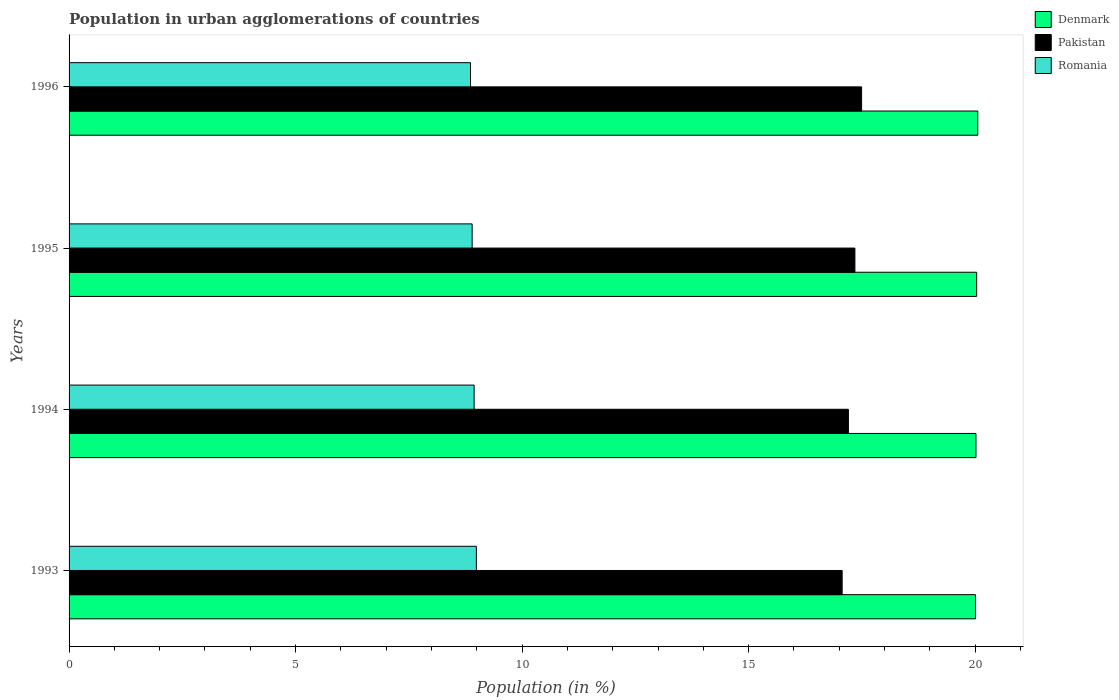How many groups of bars are there?
Provide a succinct answer. 4. Are the number of bars per tick equal to the number of legend labels?
Your answer should be compact. Yes. Are the number of bars on each tick of the Y-axis equal?
Provide a short and direct response. Yes. In how many cases, is the number of bars for a given year not equal to the number of legend labels?
Give a very brief answer. 0. What is the percentage of population in urban agglomerations in Romania in 1994?
Your answer should be compact. 8.94. Across all years, what is the maximum percentage of population in urban agglomerations in Pakistan?
Keep it short and to the point. 17.49. Across all years, what is the minimum percentage of population in urban agglomerations in Romania?
Your answer should be compact. 8.86. In which year was the percentage of population in urban agglomerations in Pakistan maximum?
Offer a very short reply. 1996. In which year was the percentage of population in urban agglomerations in Romania minimum?
Your response must be concise. 1996. What is the total percentage of population in urban agglomerations in Pakistan in the graph?
Make the answer very short. 69.1. What is the difference between the percentage of population in urban agglomerations in Denmark in 1993 and that in 1994?
Make the answer very short. -0.01. What is the difference between the percentage of population in urban agglomerations in Pakistan in 1996 and the percentage of population in urban agglomerations in Romania in 1995?
Ensure brevity in your answer.  8.6. What is the average percentage of population in urban agglomerations in Pakistan per year?
Your answer should be compact. 17.28. In the year 1996, what is the difference between the percentage of population in urban agglomerations in Pakistan and percentage of population in urban agglomerations in Denmark?
Keep it short and to the point. -2.56. What is the ratio of the percentage of population in urban agglomerations in Denmark in 1995 to that in 1996?
Your answer should be very brief. 1. Is the percentage of population in urban agglomerations in Romania in 1995 less than that in 1996?
Provide a short and direct response. No. Is the difference between the percentage of population in urban agglomerations in Pakistan in 1994 and 1995 greater than the difference between the percentage of population in urban agglomerations in Denmark in 1994 and 1995?
Ensure brevity in your answer.  No. What is the difference between the highest and the second highest percentage of population in urban agglomerations in Pakistan?
Offer a very short reply. 0.15. What is the difference between the highest and the lowest percentage of population in urban agglomerations in Pakistan?
Your answer should be compact. 0.43. In how many years, is the percentage of population in urban agglomerations in Denmark greater than the average percentage of population in urban agglomerations in Denmark taken over all years?
Keep it short and to the point. 2. Is the sum of the percentage of population in urban agglomerations in Pakistan in 1993 and 1995 greater than the maximum percentage of population in urban agglomerations in Romania across all years?
Keep it short and to the point. Yes. What does the 2nd bar from the top in 1996 represents?
Give a very brief answer. Pakistan. What does the 3rd bar from the bottom in 1993 represents?
Make the answer very short. Romania. Is it the case that in every year, the sum of the percentage of population in urban agglomerations in Romania and percentage of population in urban agglomerations in Denmark is greater than the percentage of population in urban agglomerations in Pakistan?
Give a very brief answer. Yes. How many bars are there?
Your response must be concise. 12. Are all the bars in the graph horizontal?
Provide a short and direct response. Yes. What is the difference between two consecutive major ticks on the X-axis?
Your response must be concise. 5. Does the graph contain grids?
Offer a terse response. No. Where does the legend appear in the graph?
Your response must be concise. Top right. How many legend labels are there?
Your response must be concise. 3. What is the title of the graph?
Ensure brevity in your answer.  Population in urban agglomerations of countries. What is the label or title of the Y-axis?
Your answer should be very brief. Years. What is the Population (in %) of Denmark in 1993?
Your answer should be compact. 20.01. What is the Population (in %) in Pakistan in 1993?
Keep it short and to the point. 17.06. What is the Population (in %) of Romania in 1993?
Ensure brevity in your answer.  8.99. What is the Population (in %) in Denmark in 1994?
Offer a very short reply. 20.02. What is the Population (in %) of Pakistan in 1994?
Ensure brevity in your answer.  17.2. What is the Population (in %) in Romania in 1994?
Provide a short and direct response. 8.94. What is the Population (in %) in Denmark in 1995?
Make the answer very short. 20.03. What is the Population (in %) in Pakistan in 1995?
Provide a succinct answer. 17.35. What is the Population (in %) in Romania in 1995?
Keep it short and to the point. 8.9. What is the Population (in %) of Denmark in 1996?
Give a very brief answer. 20.06. What is the Population (in %) in Pakistan in 1996?
Your answer should be compact. 17.49. What is the Population (in %) of Romania in 1996?
Your response must be concise. 8.86. Across all years, what is the maximum Population (in %) in Denmark?
Provide a succinct answer. 20.06. Across all years, what is the maximum Population (in %) of Pakistan?
Offer a very short reply. 17.49. Across all years, what is the maximum Population (in %) in Romania?
Offer a very short reply. 8.99. Across all years, what is the minimum Population (in %) of Denmark?
Make the answer very short. 20.01. Across all years, what is the minimum Population (in %) of Pakistan?
Offer a very short reply. 17.06. Across all years, what is the minimum Population (in %) of Romania?
Provide a short and direct response. 8.86. What is the total Population (in %) of Denmark in the graph?
Your response must be concise. 80.11. What is the total Population (in %) of Pakistan in the graph?
Make the answer very short. 69.1. What is the total Population (in %) of Romania in the graph?
Provide a short and direct response. 35.69. What is the difference between the Population (in %) of Denmark in 1993 and that in 1994?
Make the answer very short. -0.01. What is the difference between the Population (in %) of Pakistan in 1993 and that in 1994?
Your response must be concise. -0.14. What is the difference between the Population (in %) in Romania in 1993 and that in 1994?
Your answer should be very brief. 0.05. What is the difference between the Population (in %) in Denmark in 1993 and that in 1995?
Your response must be concise. -0.03. What is the difference between the Population (in %) in Pakistan in 1993 and that in 1995?
Offer a very short reply. -0.28. What is the difference between the Population (in %) of Romania in 1993 and that in 1995?
Ensure brevity in your answer.  0.09. What is the difference between the Population (in %) of Denmark in 1993 and that in 1996?
Your answer should be very brief. -0.05. What is the difference between the Population (in %) of Pakistan in 1993 and that in 1996?
Your response must be concise. -0.43. What is the difference between the Population (in %) in Romania in 1993 and that in 1996?
Provide a short and direct response. 0.13. What is the difference between the Population (in %) in Denmark in 1994 and that in 1995?
Make the answer very short. -0.01. What is the difference between the Population (in %) of Pakistan in 1994 and that in 1995?
Offer a terse response. -0.14. What is the difference between the Population (in %) in Romania in 1994 and that in 1995?
Keep it short and to the point. 0.04. What is the difference between the Population (in %) of Denmark in 1994 and that in 1996?
Make the answer very short. -0.04. What is the difference between the Population (in %) of Pakistan in 1994 and that in 1996?
Your response must be concise. -0.29. What is the difference between the Population (in %) of Romania in 1994 and that in 1996?
Keep it short and to the point. 0.08. What is the difference between the Population (in %) of Denmark in 1995 and that in 1996?
Ensure brevity in your answer.  -0.03. What is the difference between the Population (in %) in Pakistan in 1995 and that in 1996?
Provide a succinct answer. -0.15. What is the difference between the Population (in %) of Romania in 1995 and that in 1996?
Make the answer very short. 0.04. What is the difference between the Population (in %) of Denmark in 1993 and the Population (in %) of Pakistan in 1994?
Offer a terse response. 2.8. What is the difference between the Population (in %) of Denmark in 1993 and the Population (in %) of Romania in 1994?
Your answer should be very brief. 11.06. What is the difference between the Population (in %) of Pakistan in 1993 and the Population (in %) of Romania in 1994?
Give a very brief answer. 8.12. What is the difference between the Population (in %) in Denmark in 1993 and the Population (in %) in Pakistan in 1995?
Provide a succinct answer. 2.66. What is the difference between the Population (in %) in Denmark in 1993 and the Population (in %) in Romania in 1995?
Your response must be concise. 11.11. What is the difference between the Population (in %) of Pakistan in 1993 and the Population (in %) of Romania in 1995?
Provide a succinct answer. 8.17. What is the difference between the Population (in %) in Denmark in 1993 and the Population (in %) in Pakistan in 1996?
Provide a succinct answer. 2.51. What is the difference between the Population (in %) in Denmark in 1993 and the Population (in %) in Romania in 1996?
Keep it short and to the point. 11.14. What is the difference between the Population (in %) of Pakistan in 1993 and the Population (in %) of Romania in 1996?
Your response must be concise. 8.2. What is the difference between the Population (in %) of Denmark in 1994 and the Population (in %) of Pakistan in 1995?
Make the answer very short. 2.67. What is the difference between the Population (in %) of Denmark in 1994 and the Population (in %) of Romania in 1995?
Keep it short and to the point. 11.12. What is the difference between the Population (in %) in Pakistan in 1994 and the Population (in %) in Romania in 1995?
Your answer should be very brief. 8.3. What is the difference between the Population (in %) of Denmark in 1994 and the Population (in %) of Pakistan in 1996?
Provide a short and direct response. 2.52. What is the difference between the Population (in %) of Denmark in 1994 and the Population (in %) of Romania in 1996?
Provide a short and direct response. 11.16. What is the difference between the Population (in %) in Pakistan in 1994 and the Population (in %) in Romania in 1996?
Offer a terse response. 8.34. What is the difference between the Population (in %) in Denmark in 1995 and the Population (in %) in Pakistan in 1996?
Give a very brief answer. 2.54. What is the difference between the Population (in %) in Denmark in 1995 and the Population (in %) in Romania in 1996?
Give a very brief answer. 11.17. What is the difference between the Population (in %) in Pakistan in 1995 and the Population (in %) in Romania in 1996?
Provide a short and direct response. 8.48. What is the average Population (in %) of Denmark per year?
Provide a succinct answer. 20.03. What is the average Population (in %) in Pakistan per year?
Keep it short and to the point. 17.28. What is the average Population (in %) in Romania per year?
Ensure brevity in your answer.  8.92. In the year 1993, what is the difference between the Population (in %) in Denmark and Population (in %) in Pakistan?
Offer a terse response. 2.94. In the year 1993, what is the difference between the Population (in %) of Denmark and Population (in %) of Romania?
Your answer should be very brief. 11.02. In the year 1993, what is the difference between the Population (in %) of Pakistan and Population (in %) of Romania?
Provide a short and direct response. 8.07. In the year 1994, what is the difference between the Population (in %) of Denmark and Population (in %) of Pakistan?
Offer a terse response. 2.82. In the year 1994, what is the difference between the Population (in %) of Denmark and Population (in %) of Romania?
Offer a very short reply. 11.08. In the year 1994, what is the difference between the Population (in %) in Pakistan and Population (in %) in Romania?
Give a very brief answer. 8.26. In the year 1995, what is the difference between the Population (in %) of Denmark and Population (in %) of Pakistan?
Offer a very short reply. 2.69. In the year 1995, what is the difference between the Population (in %) of Denmark and Population (in %) of Romania?
Ensure brevity in your answer.  11.14. In the year 1995, what is the difference between the Population (in %) in Pakistan and Population (in %) in Romania?
Offer a very short reply. 8.45. In the year 1996, what is the difference between the Population (in %) of Denmark and Population (in %) of Pakistan?
Ensure brevity in your answer.  2.56. In the year 1996, what is the difference between the Population (in %) in Denmark and Population (in %) in Romania?
Offer a terse response. 11.2. In the year 1996, what is the difference between the Population (in %) of Pakistan and Population (in %) of Romania?
Provide a short and direct response. 8.63. What is the ratio of the Population (in %) in Denmark in 1993 to that in 1994?
Make the answer very short. 1. What is the ratio of the Population (in %) of Pakistan in 1993 to that in 1995?
Ensure brevity in your answer.  0.98. What is the ratio of the Population (in %) of Romania in 1993 to that in 1995?
Offer a very short reply. 1.01. What is the ratio of the Population (in %) of Pakistan in 1993 to that in 1996?
Provide a short and direct response. 0.98. What is the ratio of the Population (in %) of Romania in 1993 to that in 1996?
Offer a very short reply. 1.01. What is the ratio of the Population (in %) of Denmark in 1994 to that in 1995?
Your answer should be very brief. 1. What is the ratio of the Population (in %) in Pakistan in 1994 to that in 1995?
Give a very brief answer. 0.99. What is the ratio of the Population (in %) of Pakistan in 1994 to that in 1996?
Provide a short and direct response. 0.98. What is the ratio of the Population (in %) in Denmark in 1995 to that in 1996?
Ensure brevity in your answer.  1. What is the ratio of the Population (in %) in Pakistan in 1995 to that in 1996?
Provide a short and direct response. 0.99. What is the difference between the highest and the second highest Population (in %) of Denmark?
Offer a terse response. 0.03. What is the difference between the highest and the second highest Population (in %) in Pakistan?
Ensure brevity in your answer.  0.15. What is the difference between the highest and the second highest Population (in %) of Romania?
Your answer should be compact. 0.05. What is the difference between the highest and the lowest Population (in %) of Denmark?
Your response must be concise. 0.05. What is the difference between the highest and the lowest Population (in %) of Pakistan?
Give a very brief answer. 0.43. What is the difference between the highest and the lowest Population (in %) of Romania?
Provide a short and direct response. 0.13. 